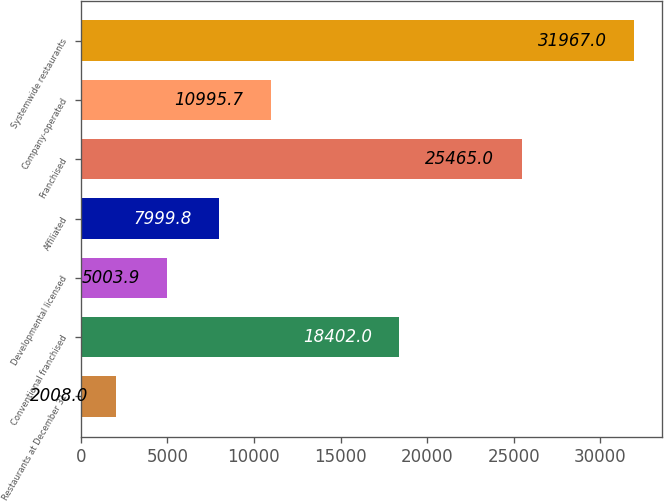Convert chart to OTSL. <chart><loc_0><loc_0><loc_500><loc_500><bar_chart><fcel>Restaurants at December 31<fcel>Conventional franchised<fcel>Developmental licensed<fcel>Affiliated<fcel>Franchised<fcel>Company-operated<fcel>Systemwide restaurants<nl><fcel>2008<fcel>18402<fcel>5003.9<fcel>7999.8<fcel>25465<fcel>10995.7<fcel>31967<nl></chart> 